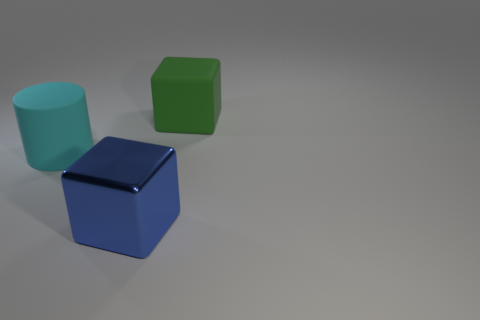Subtract all blue cubes. How many cubes are left? 1 Subtract 0 cyan blocks. How many objects are left? 3 Subtract all cylinders. How many objects are left? 2 Subtract 1 cylinders. How many cylinders are left? 0 Subtract all blue blocks. Subtract all purple cylinders. How many blocks are left? 1 Subtract all cyan spheres. How many blue cubes are left? 1 Subtract all cyan rubber cylinders. Subtract all small objects. How many objects are left? 2 Add 3 blue blocks. How many blue blocks are left? 4 Add 2 blue things. How many blue things exist? 3 Add 1 green objects. How many objects exist? 4 